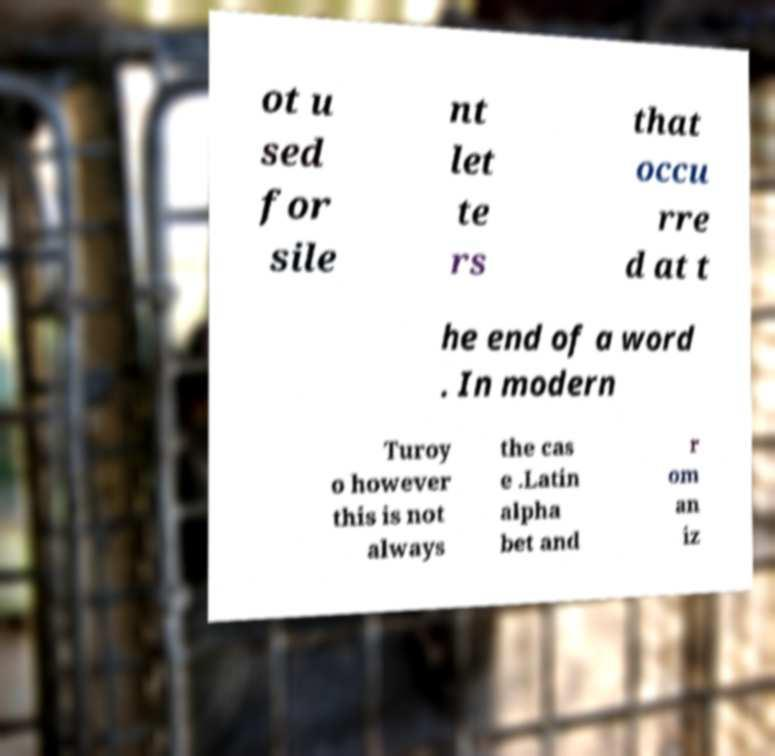What messages or text are displayed in this image? I need them in a readable, typed format. ot u sed for sile nt let te rs that occu rre d at t he end of a word . In modern Turoy o however this is not always the cas e .Latin alpha bet and r om an iz 